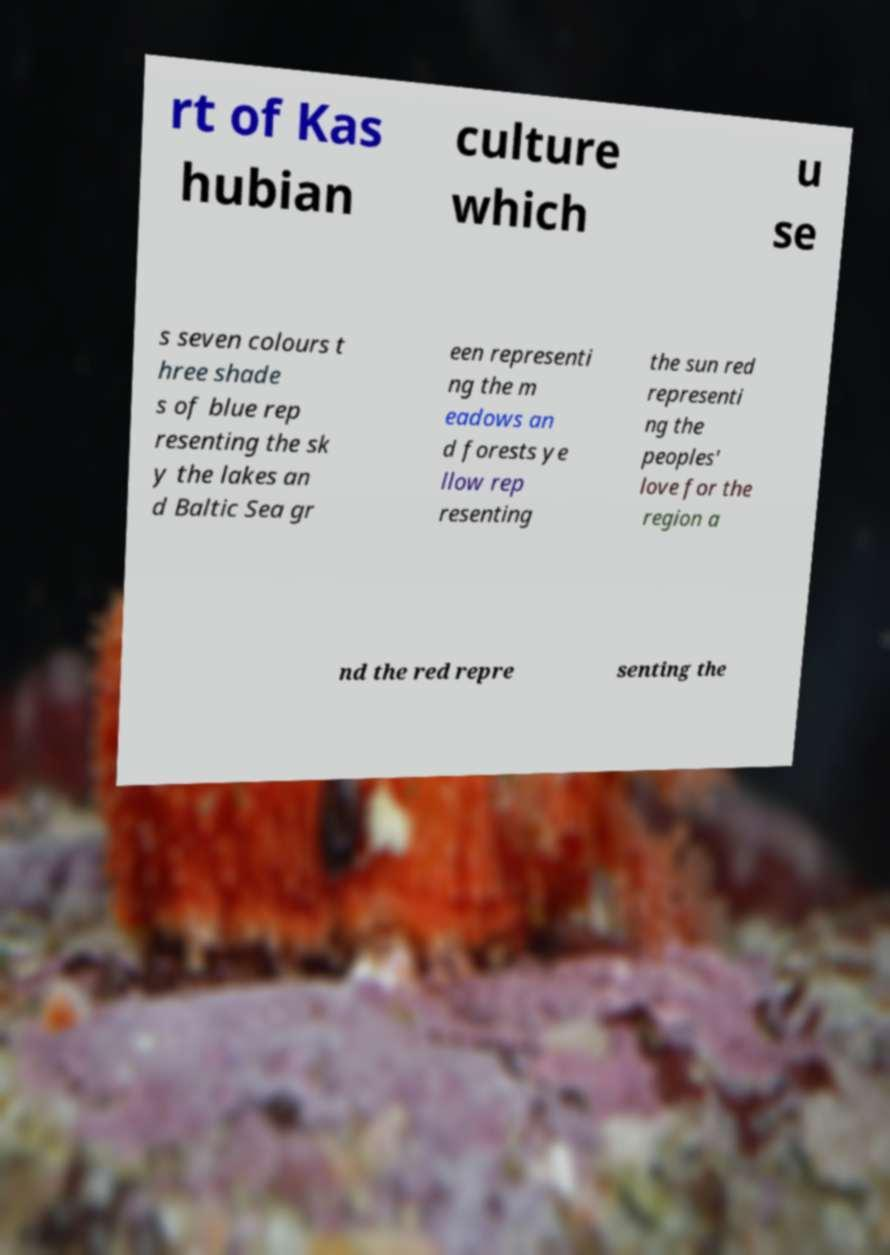I need the written content from this picture converted into text. Can you do that? rt of Kas hubian culture which u se s seven colours t hree shade s of blue rep resenting the sk y the lakes an d Baltic Sea gr een representi ng the m eadows an d forests ye llow rep resenting the sun red representi ng the peoples' love for the region a nd the red repre senting the 